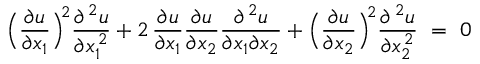Convert formula to latex. <formula><loc_0><loc_0><loc_500><loc_500>\left ( \frac { \partial u } { \partial x _ { 1 } } \right ) ^ { \, 2 } \frac { \partial ^ { \, 2 } u } { \partial x _ { 1 } ^ { \, 2 } } + 2 \, \frac { \partial u } { \partial x _ { 1 } } \frac { \partial u } { \partial x _ { 2 } } \frac { \partial ^ { \, 2 } u } { \partial x _ { 1 } \partial x _ { 2 } } + \left ( \frac { \partial u } { \partial x _ { 2 } } \right ) ^ { \, 2 } \frac { \partial { \, ^ { 2 } } u } { \partial x _ { 2 } ^ { \, 2 } } \, = \, 0</formula> 